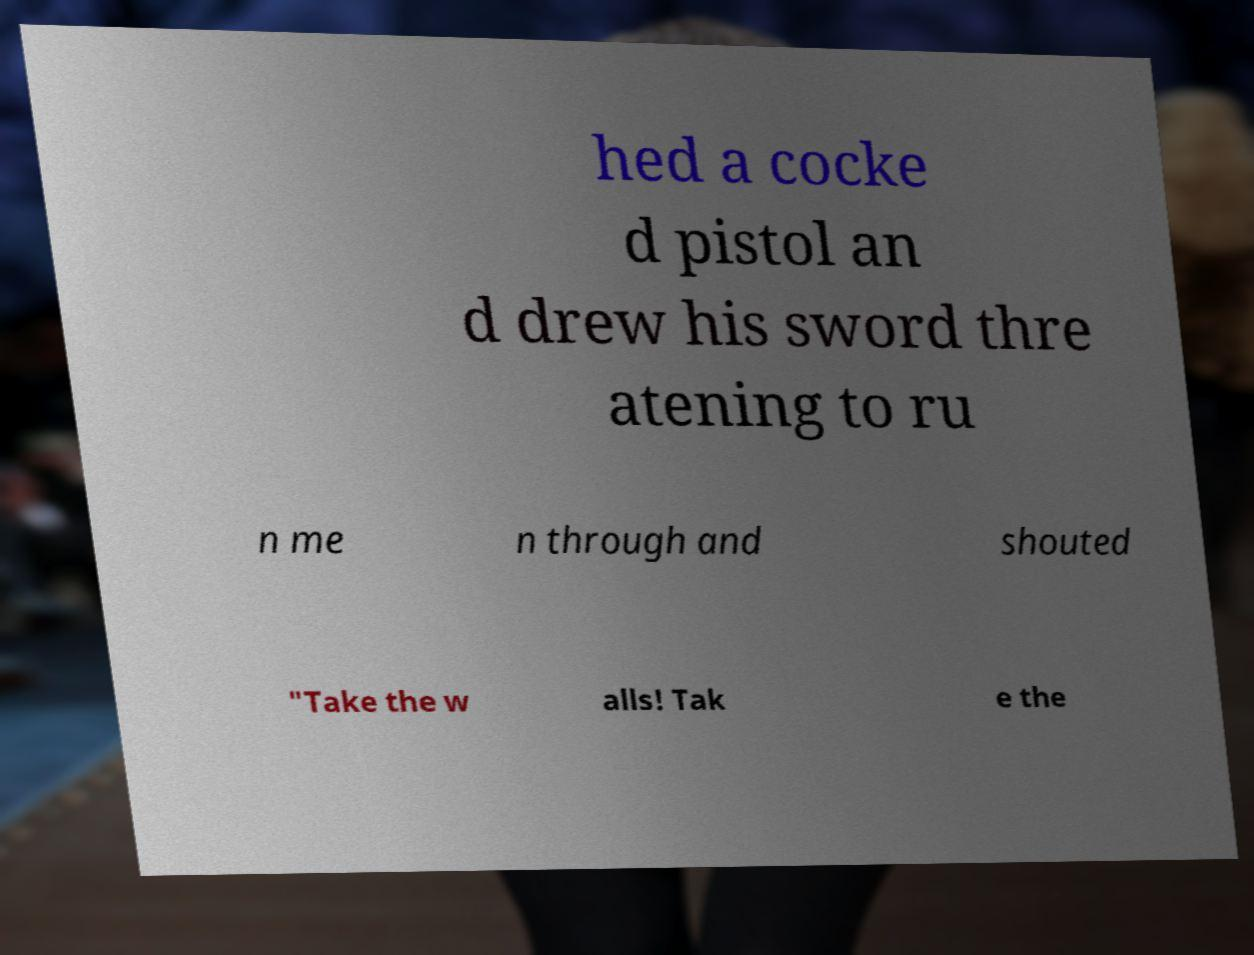Please identify and transcribe the text found in this image. hed a cocke d pistol an d drew his sword thre atening to ru n me n through and shouted "Take the w alls! Tak e the 